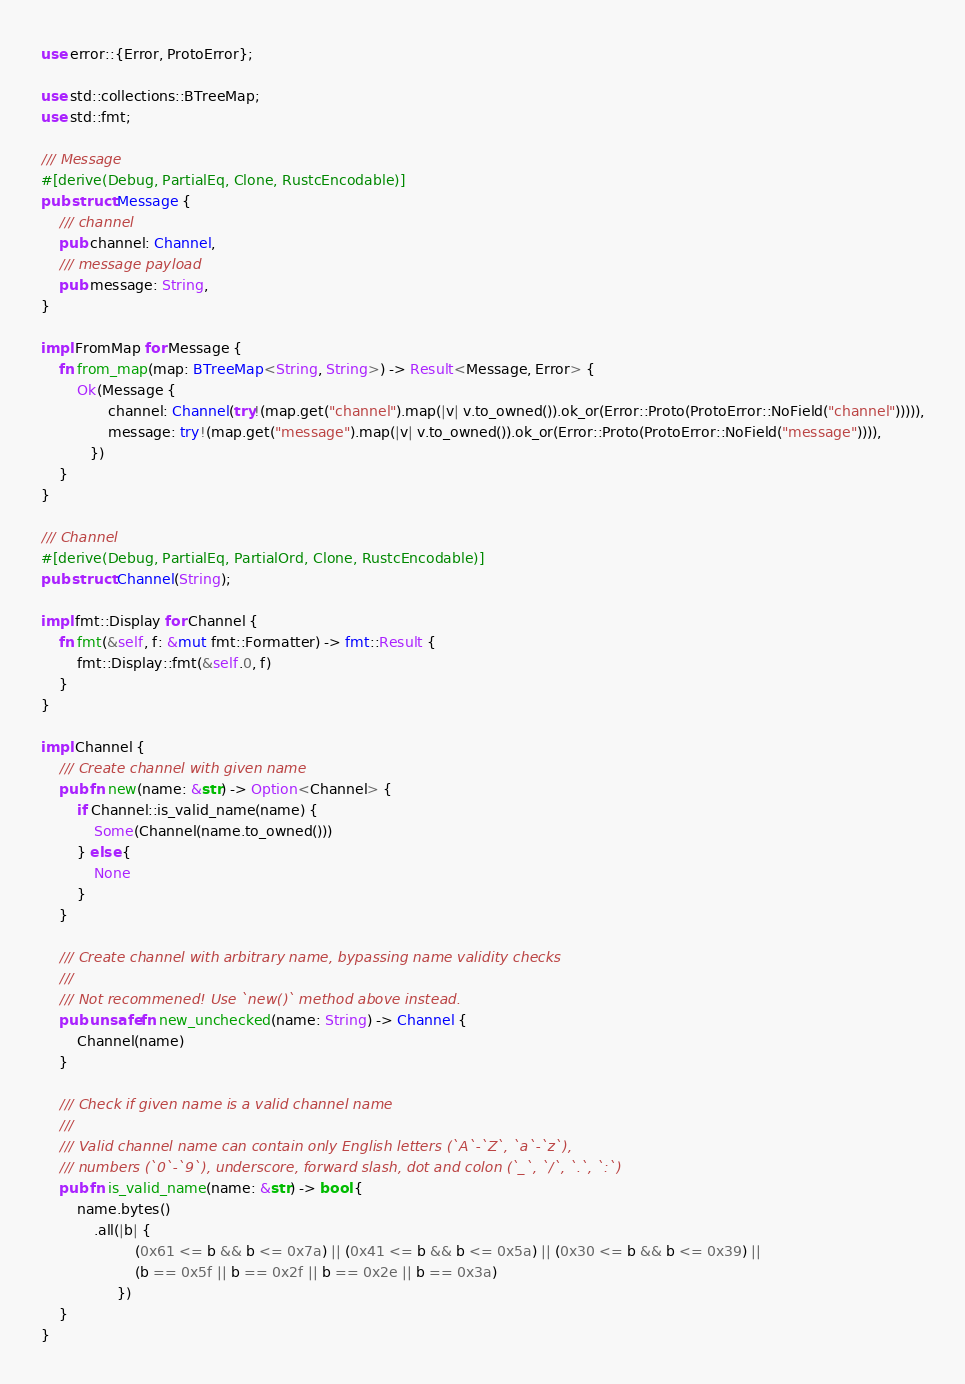Convert code to text. <code><loc_0><loc_0><loc_500><loc_500><_Rust_>
use error::{Error, ProtoError};

use std::collections::BTreeMap;
use std::fmt;

/// Message
#[derive(Debug, PartialEq, Clone, RustcEncodable)]
pub struct Message {
    /// channel
    pub channel: Channel,
    /// message payload
    pub message: String,
}

impl FromMap for Message {
    fn from_map(map: BTreeMap<String, String>) -> Result<Message, Error> {
        Ok(Message {
               channel: Channel(try!(map.get("channel").map(|v| v.to_owned()).ok_or(Error::Proto(ProtoError::NoField("channel"))))),
               message: try!(map.get("message").map(|v| v.to_owned()).ok_or(Error::Proto(ProtoError::NoField("message")))),
           })
    }
}

/// Channel
#[derive(Debug, PartialEq, PartialOrd, Clone, RustcEncodable)]
pub struct Channel(String);

impl fmt::Display for Channel {
    fn fmt(&self, f: &mut fmt::Formatter) -> fmt::Result {
        fmt::Display::fmt(&self.0, f)
    }
}

impl Channel {
    /// Create channel with given name
    pub fn new(name: &str) -> Option<Channel> {
        if Channel::is_valid_name(name) {
            Some(Channel(name.to_owned()))
        } else {
            None
        }
    }

    /// Create channel with arbitrary name, bypassing name validity checks
    ///
    /// Not recommened! Use `new()` method above instead.
    pub unsafe fn new_unchecked(name: String) -> Channel {
        Channel(name)
    }

    /// Check if given name is a valid channel name
    ///
    /// Valid channel name can contain only English letters (`A`-`Z`, `a`-`z`),
    /// numbers (`0`-`9`), underscore, forward slash, dot and colon (`_`, `/`, `.`, `:`)
    pub fn is_valid_name(name: &str) -> bool {
        name.bytes()
            .all(|b| {
                     (0x61 <= b && b <= 0x7a) || (0x41 <= b && b <= 0x5a) || (0x30 <= b && b <= 0x39) ||
                     (b == 0x5f || b == 0x2f || b == 0x2e || b == 0x3a)
                 })
    }
}
</code> 